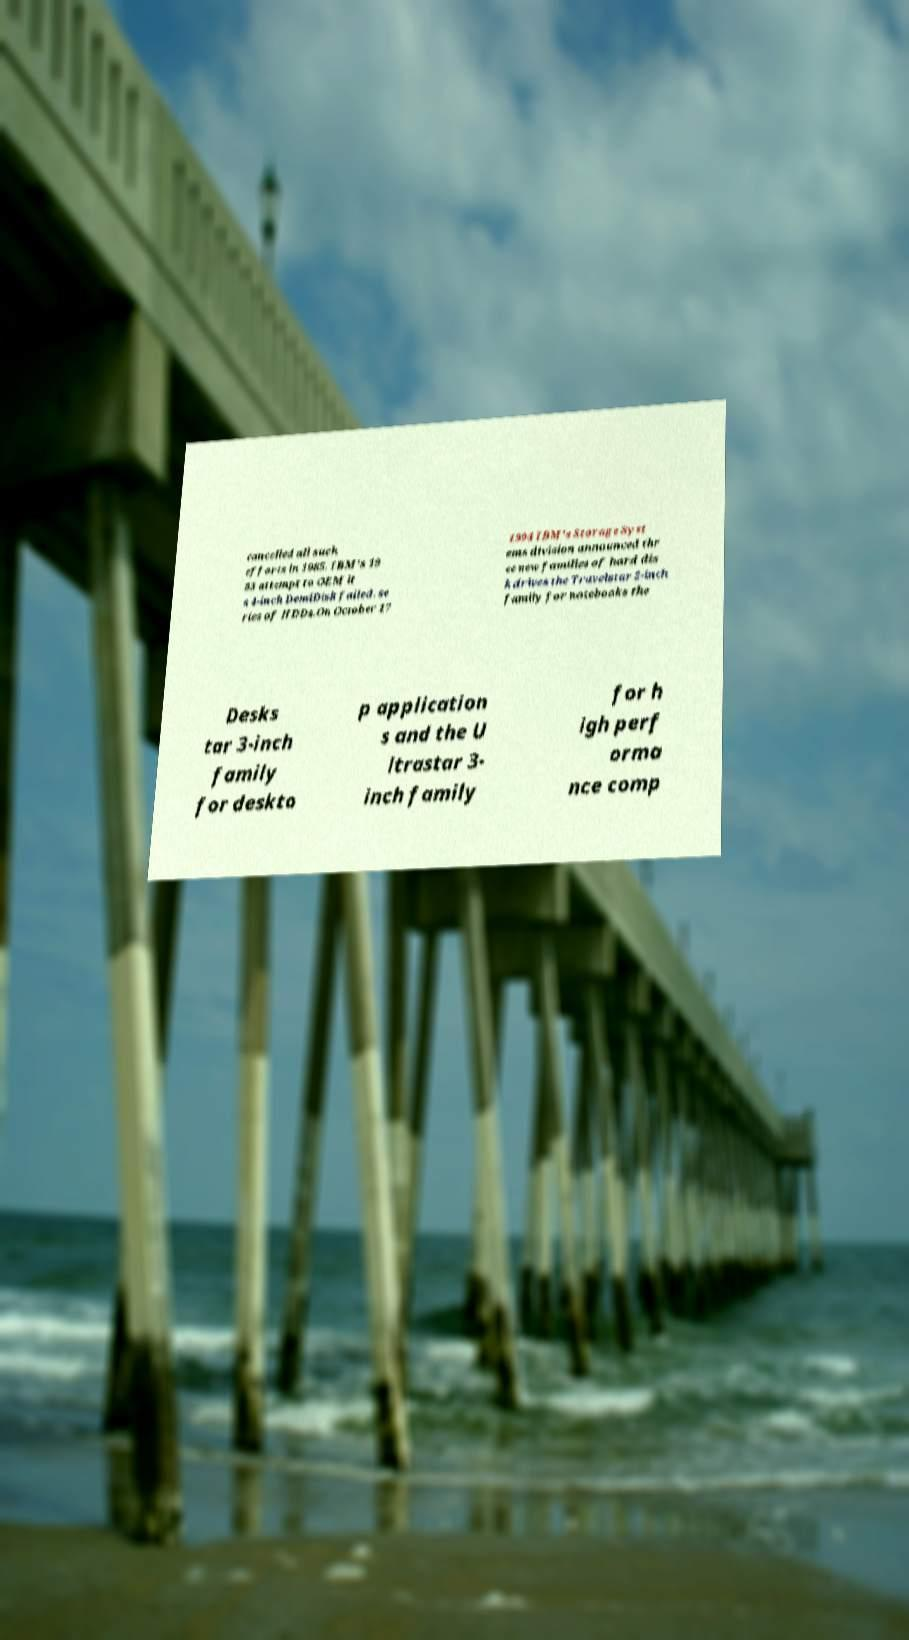There's text embedded in this image that I need extracted. Can you transcribe it verbatim? cancelled all such efforts in 1985. IBM's 19 83 attempt to OEM it s 4-inch DemiDisk failed. se ries of HDDs.On October 17 1994 IBM's Storage Syst ems division announced thr ee new families of hard dis k drives the Travelstar 2-inch family for notebooks the Desks tar 3-inch family for deskto p application s and the U ltrastar 3- inch family for h igh perf orma nce comp 